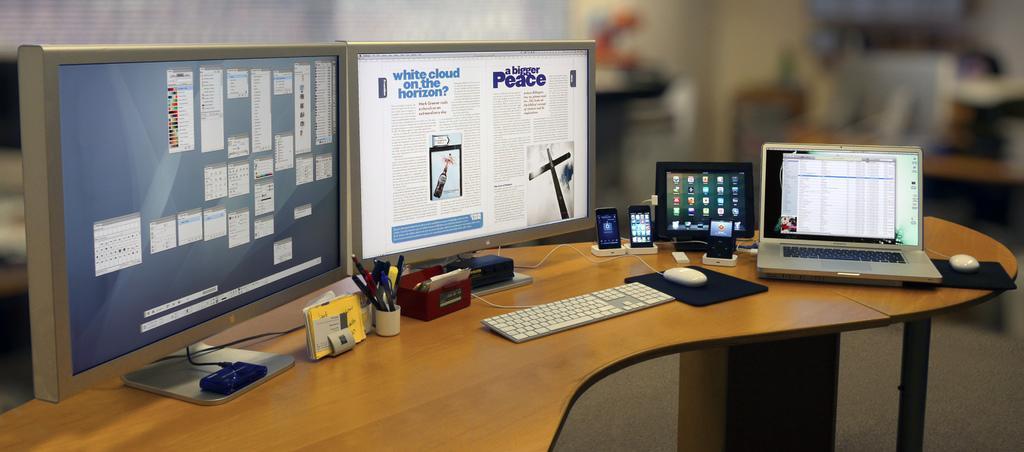Describe this image in one or two sentences. In this image we can see the monitors, mobiles, pens, keyboard, mouses and other objects. At the bottom of the image there is a wooden surface and other objects. The background of the image is blur. 